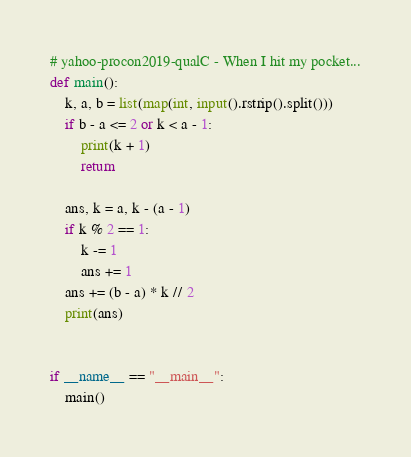<code> <loc_0><loc_0><loc_500><loc_500><_Python_># yahoo-procon2019-qualC - When I hit my pocket...
def main():
    k, a, b = list(map(int, input().rstrip().split()))
    if b - a <= 2 or k < a - 1:
        print(k + 1)
        return

    ans, k = a, k - (a - 1)
    if k % 2 == 1:
        k -= 1
        ans += 1
    ans += (b - a) * k // 2
    print(ans)


if __name__ == "__main__":
    main()</code> 